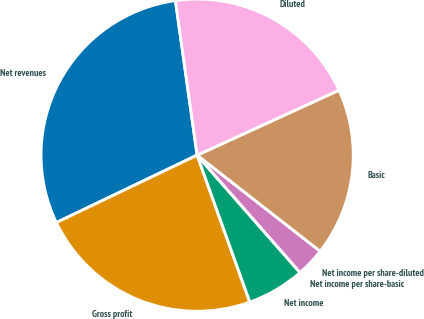Convert chart to OTSL. <chart><loc_0><loc_0><loc_500><loc_500><pie_chart><fcel>Net revenues<fcel>Gross profit<fcel>Net income<fcel>Net income per share-basic<fcel>Net income per share-diluted<fcel>Basic<fcel>Diluted<nl><fcel>29.89%<fcel>23.37%<fcel>5.98%<fcel>0.0%<fcel>2.99%<fcel>17.39%<fcel>20.38%<nl></chart> 